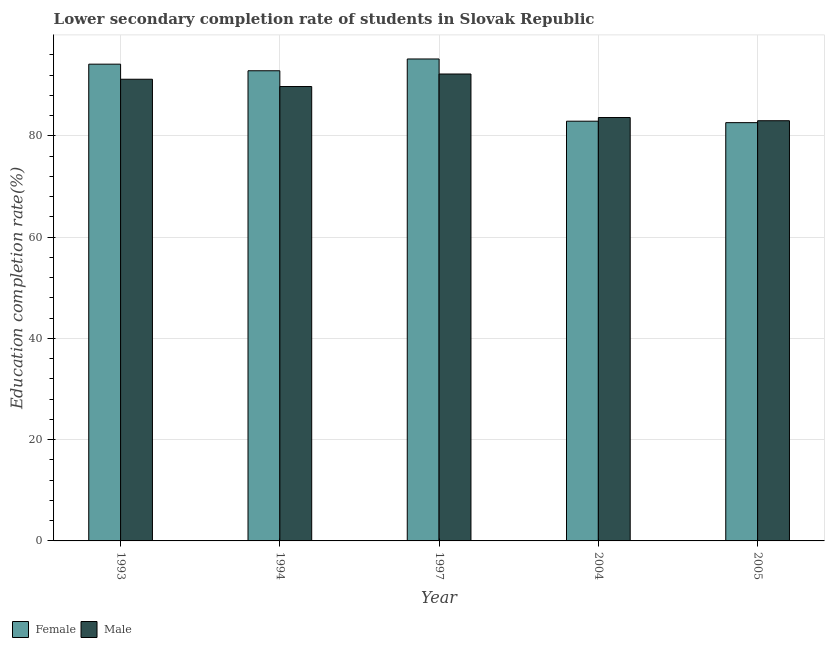How many different coloured bars are there?
Your answer should be compact. 2. How many groups of bars are there?
Offer a very short reply. 5. Are the number of bars per tick equal to the number of legend labels?
Provide a short and direct response. Yes. Are the number of bars on each tick of the X-axis equal?
Your answer should be very brief. Yes. How many bars are there on the 1st tick from the left?
Make the answer very short. 2. How many bars are there on the 1st tick from the right?
Provide a short and direct response. 2. What is the education completion rate of female students in 1997?
Your answer should be compact. 95.21. Across all years, what is the maximum education completion rate of male students?
Ensure brevity in your answer.  92.24. Across all years, what is the minimum education completion rate of female students?
Offer a terse response. 82.63. In which year was the education completion rate of female students maximum?
Your response must be concise. 1997. What is the total education completion rate of female students in the graph?
Your answer should be very brief. 447.82. What is the difference between the education completion rate of male students in 1994 and that in 1997?
Give a very brief answer. -2.47. What is the difference between the education completion rate of female students in 1993 and the education completion rate of male students in 2004?
Provide a succinct answer. 11.26. What is the average education completion rate of female students per year?
Your answer should be very brief. 89.56. In the year 1994, what is the difference between the education completion rate of male students and education completion rate of female students?
Your response must be concise. 0. What is the ratio of the education completion rate of male students in 1994 to that in 1997?
Your answer should be very brief. 0.97. What is the difference between the highest and the second highest education completion rate of female students?
Make the answer very short. 1.03. What is the difference between the highest and the lowest education completion rate of female students?
Offer a very short reply. 12.58. Is the sum of the education completion rate of female students in 1997 and 2005 greater than the maximum education completion rate of male students across all years?
Give a very brief answer. Yes. What does the 2nd bar from the left in 2005 represents?
Your response must be concise. Male. Are all the bars in the graph horizontal?
Your response must be concise. No. How many years are there in the graph?
Make the answer very short. 5. What is the difference between two consecutive major ticks on the Y-axis?
Offer a very short reply. 20. What is the title of the graph?
Ensure brevity in your answer.  Lower secondary completion rate of students in Slovak Republic. What is the label or title of the X-axis?
Your response must be concise. Year. What is the label or title of the Y-axis?
Make the answer very short. Education completion rate(%). What is the Education completion rate(%) of Female in 1993?
Your response must be concise. 94.18. What is the Education completion rate(%) in Male in 1993?
Ensure brevity in your answer.  91.2. What is the Education completion rate(%) in Female in 1994?
Your answer should be compact. 92.88. What is the Education completion rate(%) in Male in 1994?
Your answer should be compact. 89.77. What is the Education completion rate(%) in Female in 1997?
Your response must be concise. 95.21. What is the Education completion rate(%) in Male in 1997?
Make the answer very short. 92.24. What is the Education completion rate(%) of Female in 2004?
Provide a succinct answer. 82.92. What is the Education completion rate(%) of Male in 2004?
Your response must be concise. 83.64. What is the Education completion rate(%) in Female in 2005?
Provide a short and direct response. 82.63. What is the Education completion rate(%) of Male in 2005?
Your answer should be compact. 83.01. Across all years, what is the maximum Education completion rate(%) of Female?
Offer a terse response. 95.21. Across all years, what is the maximum Education completion rate(%) in Male?
Offer a very short reply. 92.24. Across all years, what is the minimum Education completion rate(%) of Female?
Give a very brief answer. 82.63. Across all years, what is the minimum Education completion rate(%) of Male?
Keep it short and to the point. 83.01. What is the total Education completion rate(%) of Female in the graph?
Offer a terse response. 447.82. What is the total Education completion rate(%) in Male in the graph?
Your response must be concise. 439.86. What is the difference between the Education completion rate(%) of Female in 1993 and that in 1994?
Make the answer very short. 1.3. What is the difference between the Education completion rate(%) of Male in 1993 and that in 1994?
Offer a very short reply. 1.44. What is the difference between the Education completion rate(%) in Female in 1993 and that in 1997?
Provide a short and direct response. -1.03. What is the difference between the Education completion rate(%) in Male in 1993 and that in 1997?
Ensure brevity in your answer.  -1.04. What is the difference between the Education completion rate(%) in Female in 1993 and that in 2004?
Keep it short and to the point. 11.26. What is the difference between the Education completion rate(%) of Male in 1993 and that in 2004?
Provide a succinct answer. 7.56. What is the difference between the Education completion rate(%) in Female in 1993 and that in 2005?
Ensure brevity in your answer.  11.55. What is the difference between the Education completion rate(%) of Male in 1993 and that in 2005?
Provide a succinct answer. 8.19. What is the difference between the Education completion rate(%) in Female in 1994 and that in 1997?
Offer a very short reply. -2.33. What is the difference between the Education completion rate(%) in Male in 1994 and that in 1997?
Offer a very short reply. -2.47. What is the difference between the Education completion rate(%) of Female in 1994 and that in 2004?
Your answer should be very brief. 9.96. What is the difference between the Education completion rate(%) of Male in 1994 and that in 2004?
Provide a short and direct response. 6.12. What is the difference between the Education completion rate(%) in Female in 1994 and that in 2005?
Keep it short and to the point. 10.25. What is the difference between the Education completion rate(%) of Male in 1994 and that in 2005?
Keep it short and to the point. 6.76. What is the difference between the Education completion rate(%) in Female in 1997 and that in 2004?
Give a very brief answer. 12.29. What is the difference between the Education completion rate(%) in Male in 1997 and that in 2004?
Provide a short and direct response. 8.6. What is the difference between the Education completion rate(%) of Female in 1997 and that in 2005?
Keep it short and to the point. 12.58. What is the difference between the Education completion rate(%) in Male in 1997 and that in 2005?
Keep it short and to the point. 9.23. What is the difference between the Education completion rate(%) of Female in 2004 and that in 2005?
Provide a succinct answer. 0.29. What is the difference between the Education completion rate(%) of Male in 2004 and that in 2005?
Your answer should be very brief. 0.63. What is the difference between the Education completion rate(%) in Female in 1993 and the Education completion rate(%) in Male in 1994?
Your answer should be very brief. 4.42. What is the difference between the Education completion rate(%) in Female in 1993 and the Education completion rate(%) in Male in 1997?
Give a very brief answer. 1.94. What is the difference between the Education completion rate(%) in Female in 1993 and the Education completion rate(%) in Male in 2004?
Make the answer very short. 10.54. What is the difference between the Education completion rate(%) of Female in 1993 and the Education completion rate(%) of Male in 2005?
Your answer should be compact. 11.17. What is the difference between the Education completion rate(%) of Female in 1994 and the Education completion rate(%) of Male in 1997?
Ensure brevity in your answer.  0.64. What is the difference between the Education completion rate(%) of Female in 1994 and the Education completion rate(%) of Male in 2004?
Your answer should be compact. 9.24. What is the difference between the Education completion rate(%) of Female in 1994 and the Education completion rate(%) of Male in 2005?
Your answer should be compact. 9.87. What is the difference between the Education completion rate(%) of Female in 1997 and the Education completion rate(%) of Male in 2004?
Offer a very short reply. 11.57. What is the difference between the Education completion rate(%) of Female in 1997 and the Education completion rate(%) of Male in 2005?
Offer a very short reply. 12.2. What is the difference between the Education completion rate(%) of Female in 2004 and the Education completion rate(%) of Male in 2005?
Keep it short and to the point. -0.09. What is the average Education completion rate(%) in Female per year?
Keep it short and to the point. 89.56. What is the average Education completion rate(%) of Male per year?
Provide a succinct answer. 87.97. In the year 1993, what is the difference between the Education completion rate(%) of Female and Education completion rate(%) of Male?
Provide a succinct answer. 2.98. In the year 1994, what is the difference between the Education completion rate(%) in Female and Education completion rate(%) in Male?
Give a very brief answer. 3.11. In the year 1997, what is the difference between the Education completion rate(%) of Female and Education completion rate(%) of Male?
Your answer should be compact. 2.97. In the year 2004, what is the difference between the Education completion rate(%) of Female and Education completion rate(%) of Male?
Keep it short and to the point. -0.73. In the year 2005, what is the difference between the Education completion rate(%) of Female and Education completion rate(%) of Male?
Give a very brief answer. -0.38. What is the ratio of the Education completion rate(%) in Male in 1993 to that in 1994?
Give a very brief answer. 1.02. What is the ratio of the Education completion rate(%) in Male in 1993 to that in 1997?
Keep it short and to the point. 0.99. What is the ratio of the Education completion rate(%) of Female in 1993 to that in 2004?
Ensure brevity in your answer.  1.14. What is the ratio of the Education completion rate(%) in Male in 1993 to that in 2004?
Ensure brevity in your answer.  1.09. What is the ratio of the Education completion rate(%) of Female in 1993 to that in 2005?
Ensure brevity in your answer.  1.14. What is the ratio of the Education completion rate(%) of Male in 1993 to that in 2005?
Your response must be concise. 1.1. What is the ratio of the Education completion rate(%) of Female in 1994 to that in 1997?
Keep it short and to the point. 0.98. What is the ratio of the Education completion rate(%) in Male in 1994 to that in 1997?
Your answer should be very brief. 0.97. What is the ratio of the Education completion rate(%) of Female in 1994 to that in 2004?
Offer a very short reply. 1.12. What is the ratio of the Education completion rate(%) of Male in 1994 to that in 2004?
Provide a succinct answer. 1.07. What is the ratio of the Education completion rate(%) in Female in 1994 to that in 2005?
Offer a very short reply. 1.12. What is the ratio of the Education completion rate(%) of Male in 1994 to that in 2005?
Your response must be concise. 1.08. What is the ratio of the Education completion rate(%) in Female in 1997 to that in 2004?
Offer a very short reply. 1.15. What is the ratio of the Education completion rate(%) of Male in 1997 to that in 2004?
Give a very brief answer. 1.1. What is the ratio of the Education completion rate(%) of Female in 1997 to that in 2005?
Your answer should be compact. 1.15. What is the ratio of the Education completion rate(%) in Male in 1997 to that in 2005?
Offer a terse response. 1.11. What is the ratio of the Education completion rate(%) in Female in 2004 to that in 2005?
Offer a terse response. 1. What is the ratio of the Education completion rate(%) of Male in 2004 to that in 2005?
Make the answer very short. 1.01. What is the difference between the highest and the second highest Education completion rate(%) in Female?
Offer a terse response. 1.03. What is the difference between the highest and the second highest Education completion rate(%) of Male?
Your answer should be very brief. 1.04. What is the difference between the highest and the lowest Education completion rate(%) in Female?
Keep it short and to the point. 12.58. What is the difference between the highest and the lowest Education completion rate(%) in Male?
Ensure brevity in your answer.  9.23. 